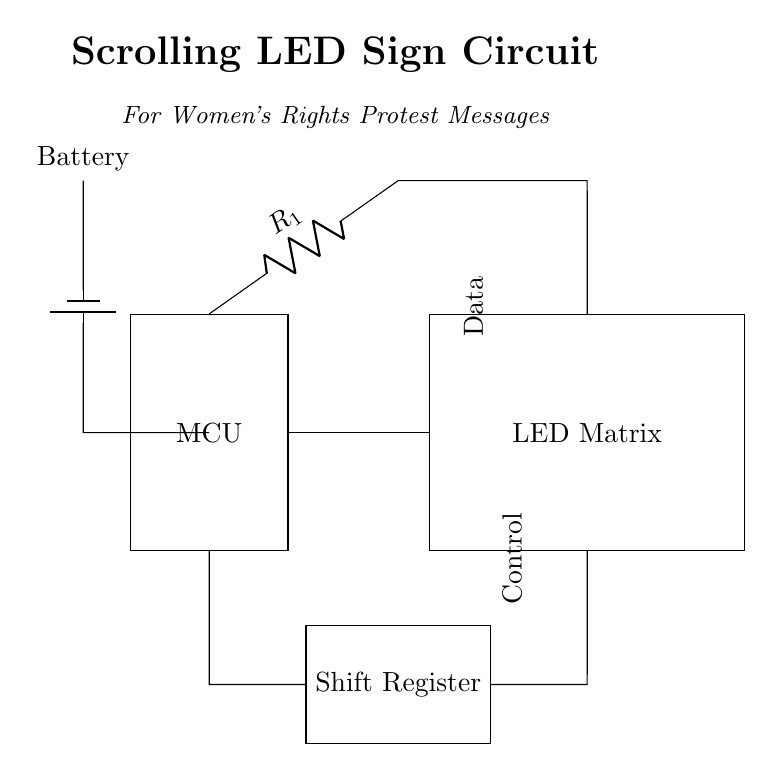What components are included in this circuit? The circuit includes a microcontroller (MCU), an LED matrix, a shift register, and a battery. Each component is clearly labeled in the diagram, making it easy to identify them.
Answer: microcontroller, LED matrix, shift register, battery What is the function of the shift register in this circuit? The shift register is used to manage data flow from the microcontroller to the LED matrix, allowing for the control of the individual LEDs for scrolling messages. Its position between the MCU and LED matrix in the diagram indicates its role in data control.
Answer: Data management How is the power supplied to the circuit? The power is supplied by a battery connected to the microcontroller, which indicates the circuit's need for a portable power source. The diagram clearly shows the battery connected to the MCU.
Answer: Battery What does the resistor in the circuit specifically do? The resistor in the circuit is typically used to limit the current flowing to the LED matrix, preventing damage due to excess current. Its placement between the MCU and the LED matrix suggests it is directly involved in current regulation.
Answer: Current limiting How many main components are there that actively control the LED display? There are two main components that actively control the LED display: the microcontroller and the shift register. The MCU generates the control signals, while the shift register processes the data for sending to the LED matrix.
Answer: Two What type of circuit is represented here? The circuit is a digital circuit, as indicated by the presence of a microcontroller and a shift register, both of which serve digital logic functions crucial for controlling the LED display.
Answer: Digital 